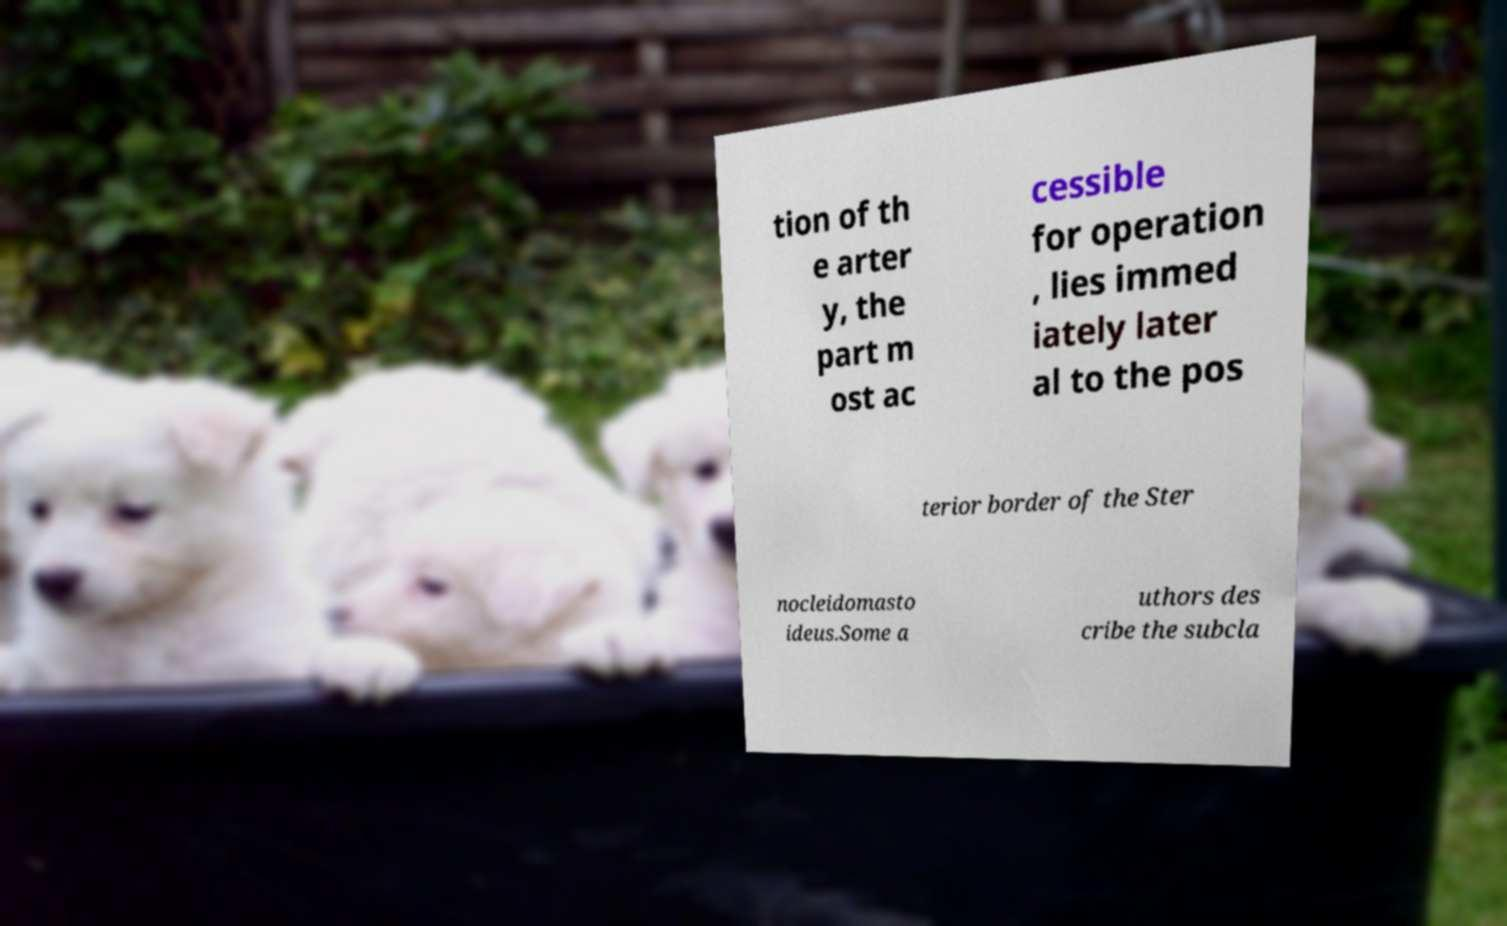There's text embedded in this image that I need extracted. Can you transcribe it verbatim? tion of th e arter y, the part m ost ac cessible for operation , lies immed iately later al to the pos terior border of the Ster nocleidomasto ideus.Some a uthors des cribe the subcla 